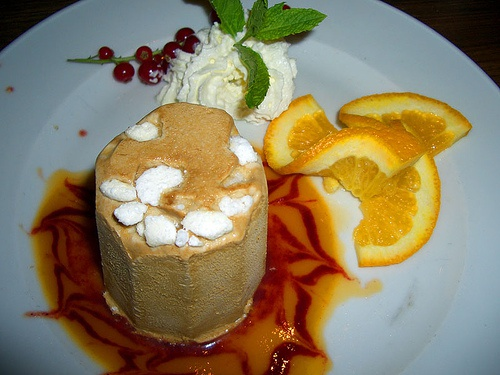Describe the objects in this image and their specific colors. I can see cake in black, olive, tan, and white tones, orange in black, orange, and khaki tones, orange in black, orange, khaki, and gold tones, and orange in black, olive, orange, and khaki tones in this image. 